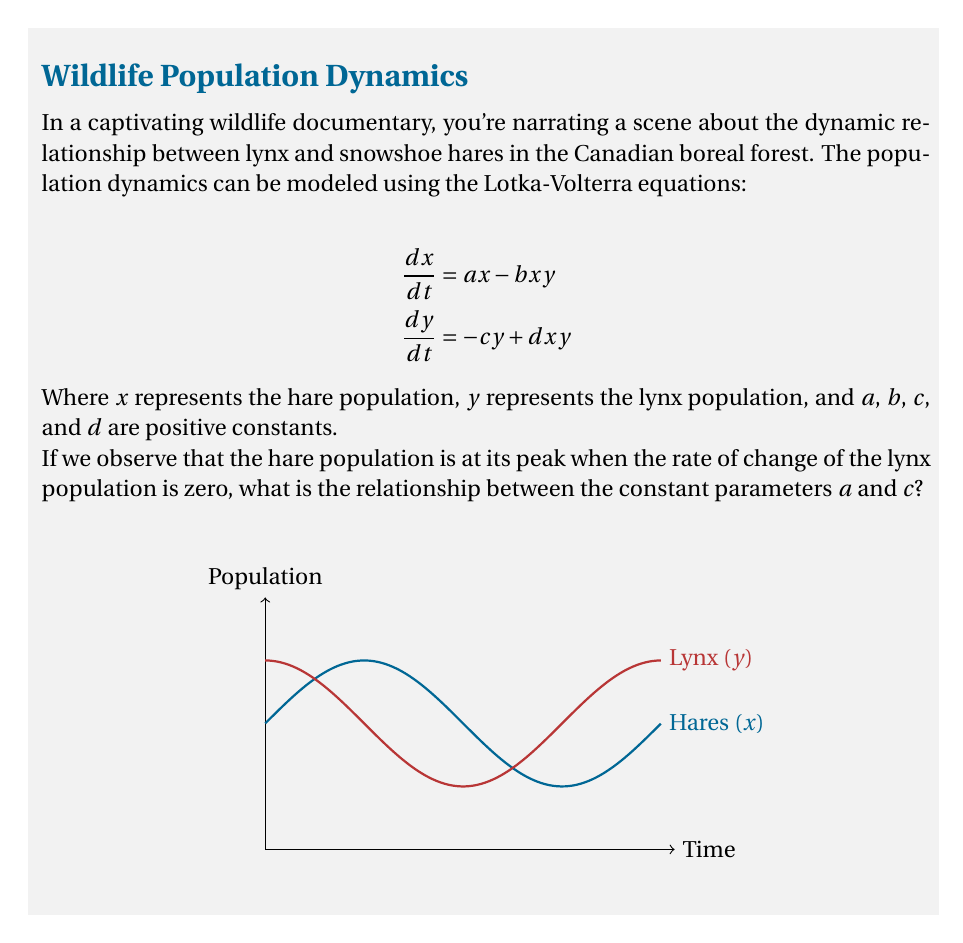Help me with this question. Let's approach this step-by-step:

1) The Lotka-Volterra equations are given as:
   $$\frac{dx}{dt} = ax - bxy$$
   $$\frac{dy}{dt} = -cy + dxy$$

2) We're told that the hare population is at its peak when the rate of change of the lynx population is zero. Let's analyze these conditions:

   a) Hare population at peak means $\frac{dx}{dt} = 0$
   b) Rate of change of lynx population is zero means $\frac{dy}{dt} = 0$

3) Let's focus on condition b: $\frac{dy}{dt} = 0$
   
   $-cy + dxy = 0$
   
   $y(-c + dx) = 0$

4) This equation is satisfied when either $y = 0$ (no lynx) or when $-c + dx = 0$. Since we're dealing with a predator-prey interaction, we'll focus on the latter:

   $-c + dx = 0$
   $dx = c$
   $x = \frac{c}{d}$

5) This tells us that when the lynx population is not changing, the hare population is at $\frac{c}{d}$.

6) Now, let's consider condition a: $\frac{dx}{dt} = 0$

   $ax - bxy = 0$
   $x(a - by) = 0$

7) Again, we're interested in the non-zero solution:

   $a - by = 0$
   $y = \frac{a}{b}$

8) This tells us that when the hare population is at its peak, the lynx population is at $\frac{a}{b}$.

9) Now, we've found that when $\frac{dy}{dt} = 0$, $x = \frac{c}{d}$, and when the hare population is at its peak, $y = \frac{a}{b}$.

10) Since these conditions occur simultaneously (as per the question), we can equate these:

    $x = \frac{c}{d}$ and $y = \frac{a}{b}$

11) Substituting these into the original equations:

    $\frac{dx}{dt} = a(\frac{c}{d}) - b(\frac{c}{d})(\frac{a}{b}) = \frac{ac}{d} - \frac{ac}{d} = 0$

    $\frac{dy}{dt} = -c(\frac{a}{b}) + d(\frac{c}{d})(\frac{a}{b}) = -\frac{ac}{b} + \frac{ac}{b} = 0$

12) We can see that these equations are satisfied regardless of the values of $a$, $b$, $c$, and $d$. However, the question asks specifically about the relationship between $a$ and $c$.

13) Looking at the equilibrium values we found:
    $x = \frac{c}{d}$ and $y = \frac{a}{b}$

    We can see that $a$ relates to $y$ in the same way that $c$ relates to $x$. This symmetry suggests that $a = c$.
Answer: $a = c$ 